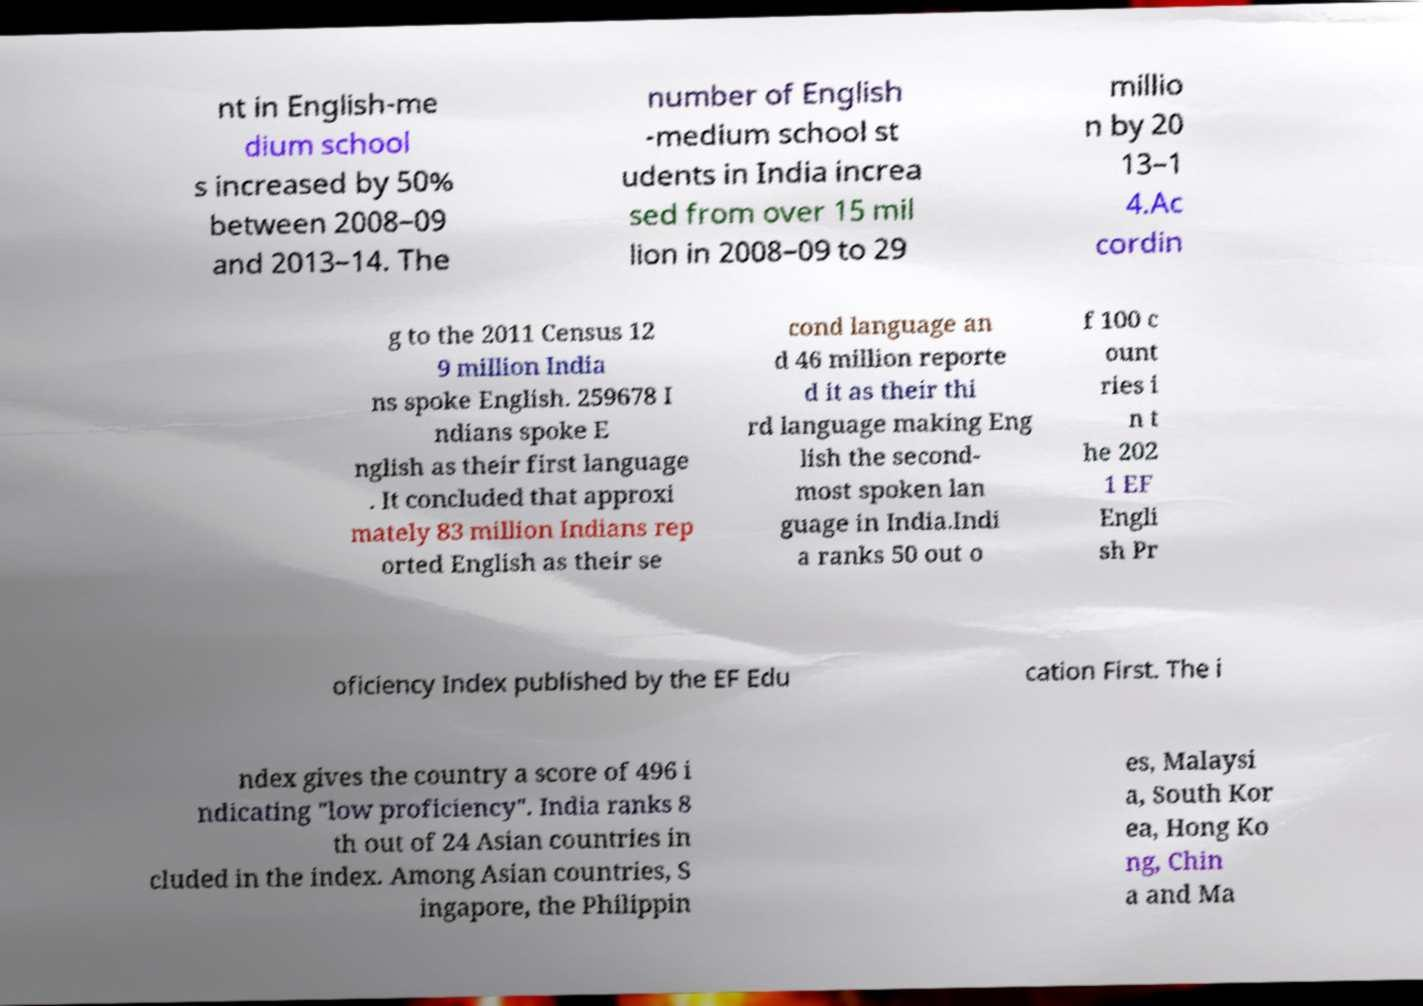Could you extract and type out the text from this image? nt in English-me dium school s increased by 50% between 2008–09 and 2013–14. The number of English -medium school st udents in India increa sed from over 15 mil lion in 2008–09 to 29 millio n by 20 13–1 4.Ac cordin g to the 2011 Census 12 9 million India ns spoke English. 259678 I ndians spoke E nglish as their first language . It concluded that approxi mately 83 million Indians rep orted English as their se cond language an d 46 million reporte d it as their thi rd language making Eng lish the second- most spoken lan guage in India.Indi a ranks 50 out o f 100 c ount ries i n t he 202 1 EF Engli sh Pr oficiency Index published by the EF Edu cation First. The i ndex gives the country a score of 496 i ndicating "low proficiency". India ranks 8 th out of 24 Asian countries in cluded in the index. Among Asian countries, S ingapore, the Philippin es, Malaysi a, South Kor ea, Hong Ko ng, Chin a and Ma 